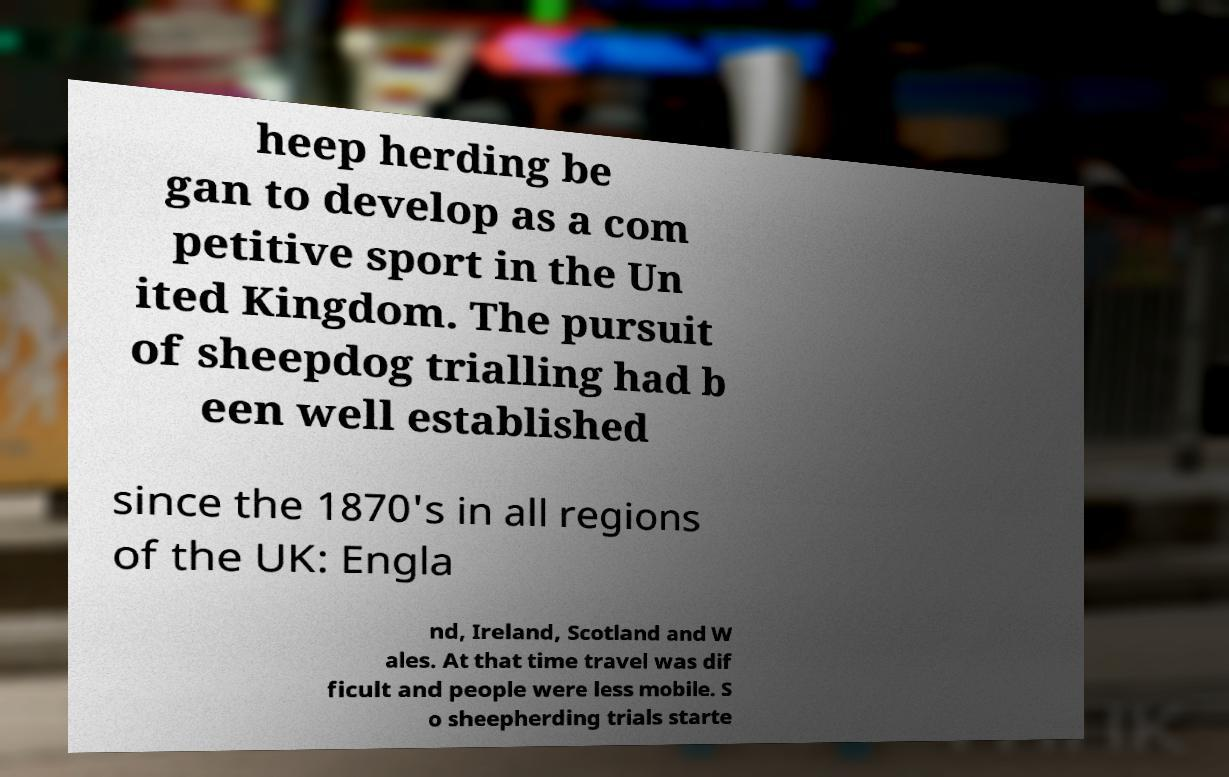Can you read and provide the text displayed in the image?This photo seems to have some interesting text. Can you extract and type it out for me? heep herding be gan to develop as a com petitive sport in the Un ited Kingdom. The pursuit of sheepdog trialling had b een well established since the 1870's in all regions of the UK: Engla nd, Ireland, Scotland and W ales. At that time travel was dif ficult and people were less mobile. S o sheepherding trials starte 